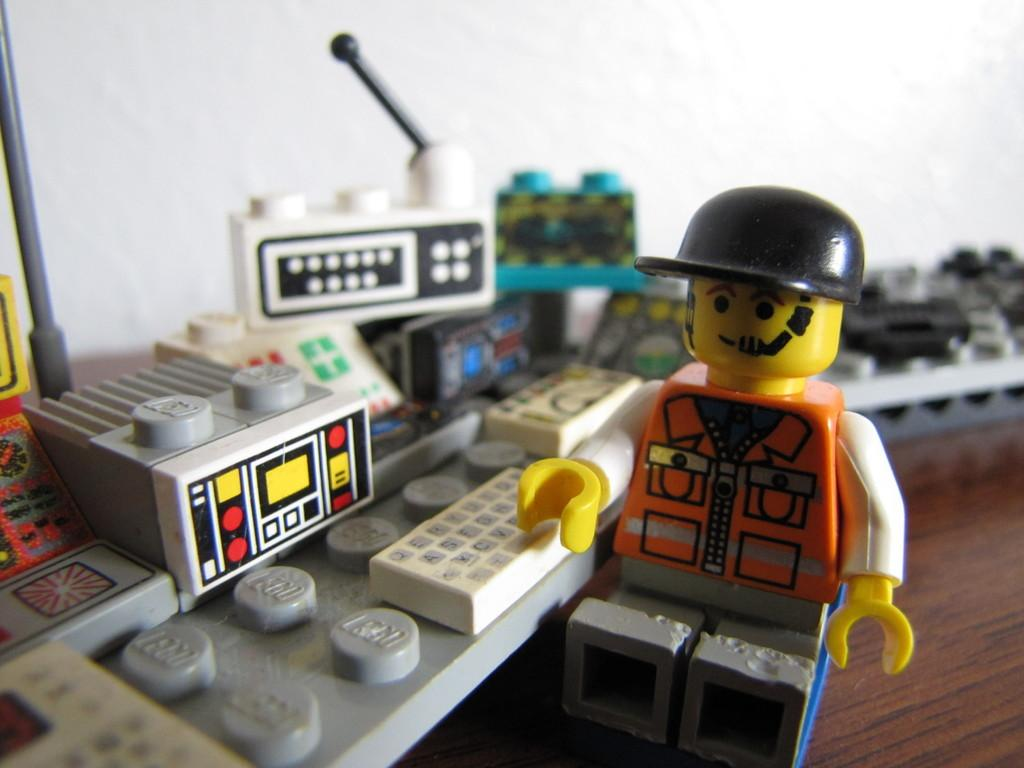What type of furniture is visible in the image? There is a table in the image. What items are on the table? Legos and a toy are present on the table. What can be seen in the background of the image? There is a wall in the background of the image. How does the sheet help the Legos stay organized on the table? There is no sheet present in the image, so it cannot help organize the Legos. 